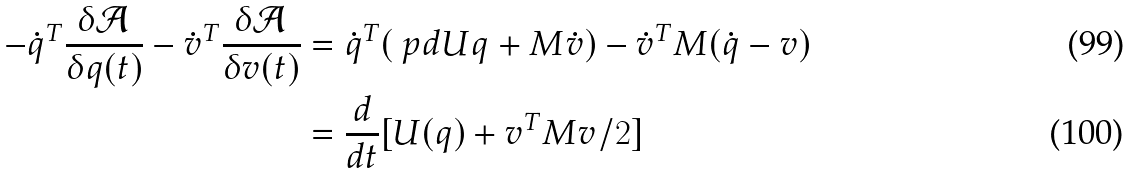Convert formula to latex. <formula><loc_0><loc_0><loc_500><loc_500>- \dot { q } ^ { T } \frac { \delta \mathcal { A } } { \delta q ( t ) } - \dot { v } ^ { T } \frac { \delta \mathcal { A } } { \delta v ( t ) } & = \dot { q } ^ { T } ( \ p d { U } { q } + M \dot { v } ) - \dot { v } ^ { T } M ( \dot { q } - v ) \\ & = \frac { d } { d t } [ U ( q ) + v ^ { T } M v / 2 ]</formula> 